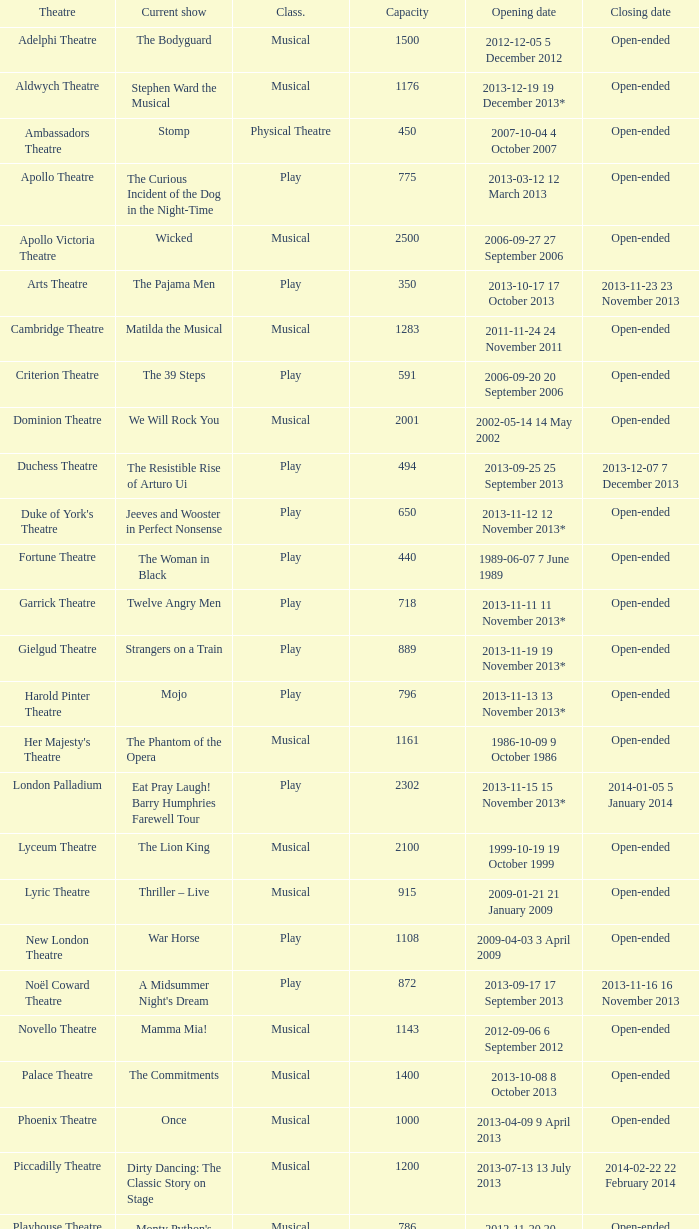What opening date has a capacity of 100? 2013-11-01 1 November 2013. 